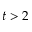Convert formula to latex. <formula><loc_0><loc_0><loc_500><loc_500>t > 2</formula> 